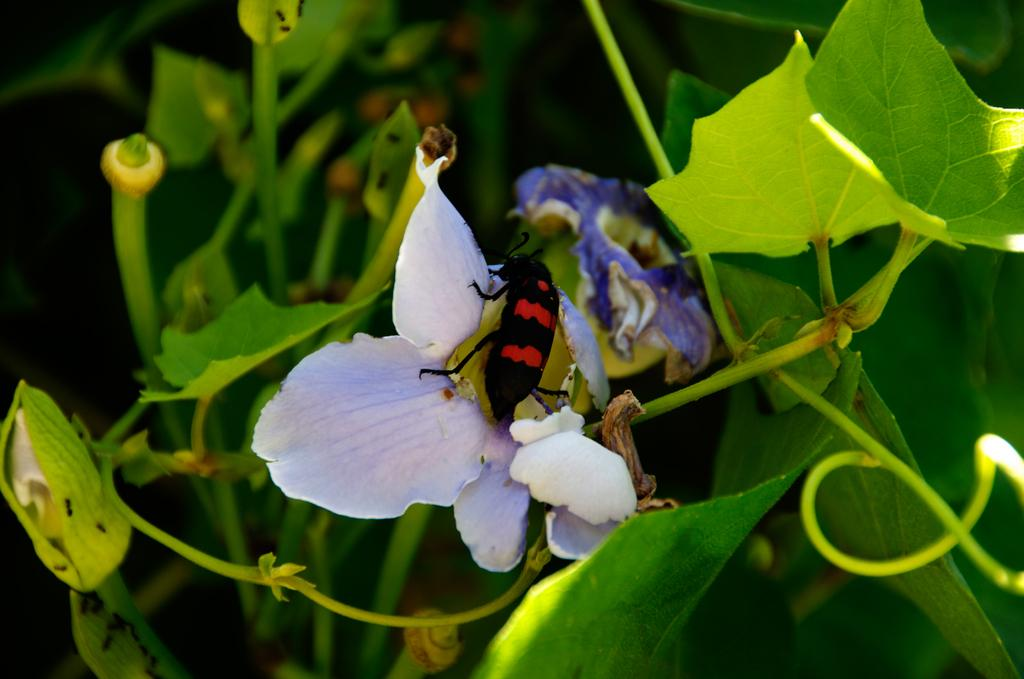What is the main subject in the center of the image? There is a moth in the center of the image. What is the moth doing or resting on? The moth is on a flower. What can be seen in the background of the image? There are plants in the background of the image. How many chickens are visible in the image? There are no chickens present in the image. Is there a man holding the moth in the image? There is no man present in the image; the moth is on a flower. 